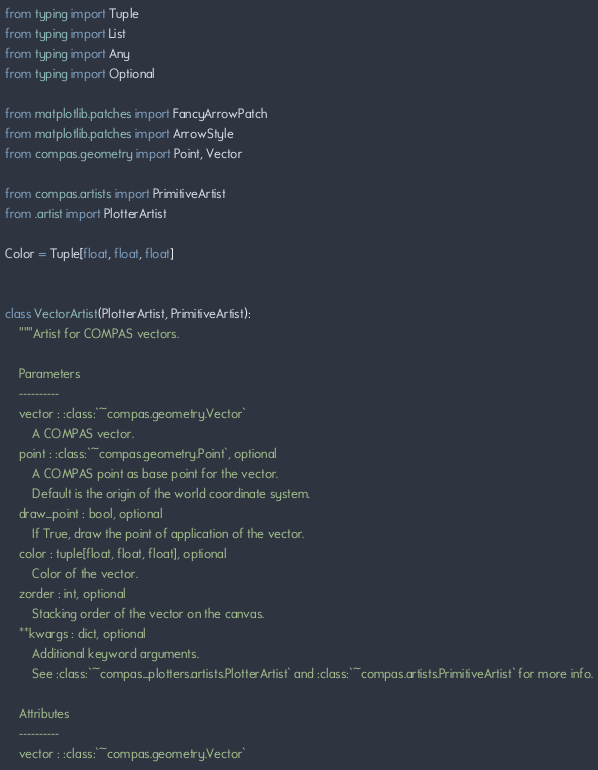<code> <loc_0><loc_0><loc_500><loc_500><_Python_>from typing import Tuple
from typing import List
from typing import Any
from typing import Optional

from matplotlib.patches import FancyArrowPatch
from matplotlib.patches import ArrowStyle
from compas.geometry import Point, Vector

from compas.artists import PrimitiveArtist
from .artist import PlotterArtist

Color = Tuple[float, float, float]


class VectorArtist(PlotterArtist, PrimitiveArtist):
    """Artist for COMPAS vectors.

    Parameters
    ----------
    vector : :class:`~compas.geometry.Vector`
        A COMPAS vector.
    point : :class:`~compas.geometry.Point`, optional
        A COMPAS point as base point for the vector.
        Default is the origin of the world coordinate system.
    draw_point : bool, optional
        If True, draw the point of application of the vector.
    color : tuple[float, float, float], optional
        Color of the vector.
    zorder : int, optional
        Stacking order of the vector on the canvas.
    **kwargs : dict, optional
        Additional keyword arguments.
        See :class:`~compas_plotters.artists.PlotterArtist` and :class:`~compas.artists.PrimitiveArtist` for more info.

    Attributes
    ----------
    vector : :class:`~compas.geometry.Vector`</code> 